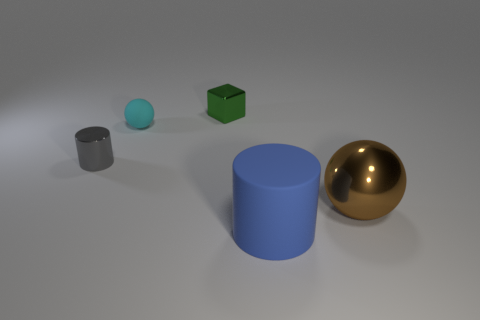Subtract all purple cylinders. Subtract all cyan cubes. How many cylinders are left? 2 Add 4 large cyan cylinders. How many objects exist? 9 Subtract all blocks. How many objects are left? 4 Add 5 big gray shiny spheres. How many big gray shiny spheres exist? 5 Subtract 0 red balls. How many objects are left? 5 Subtract all small gray objects. Subtract all gray matte balls. How many objects are left? 4 Add 3 matte cylinders. How many matte cylinders are left? 4 